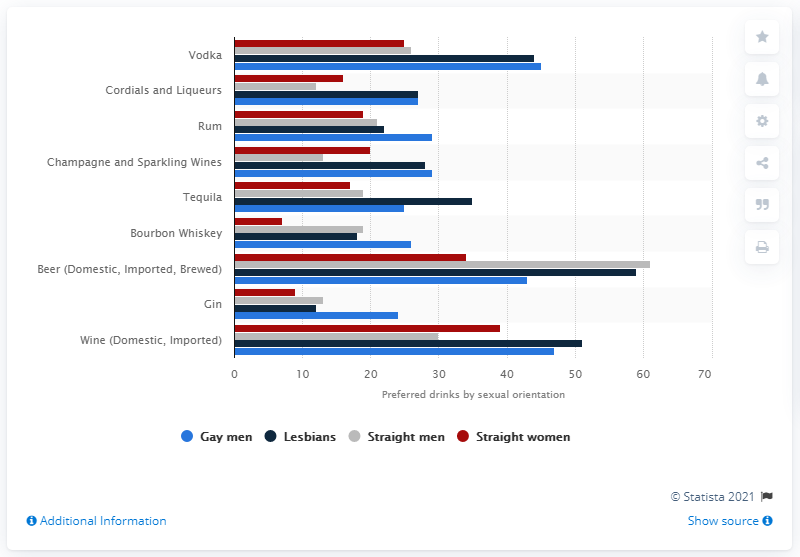What percentage of gay and lesbian respondents said they drink Vodka?
 45 